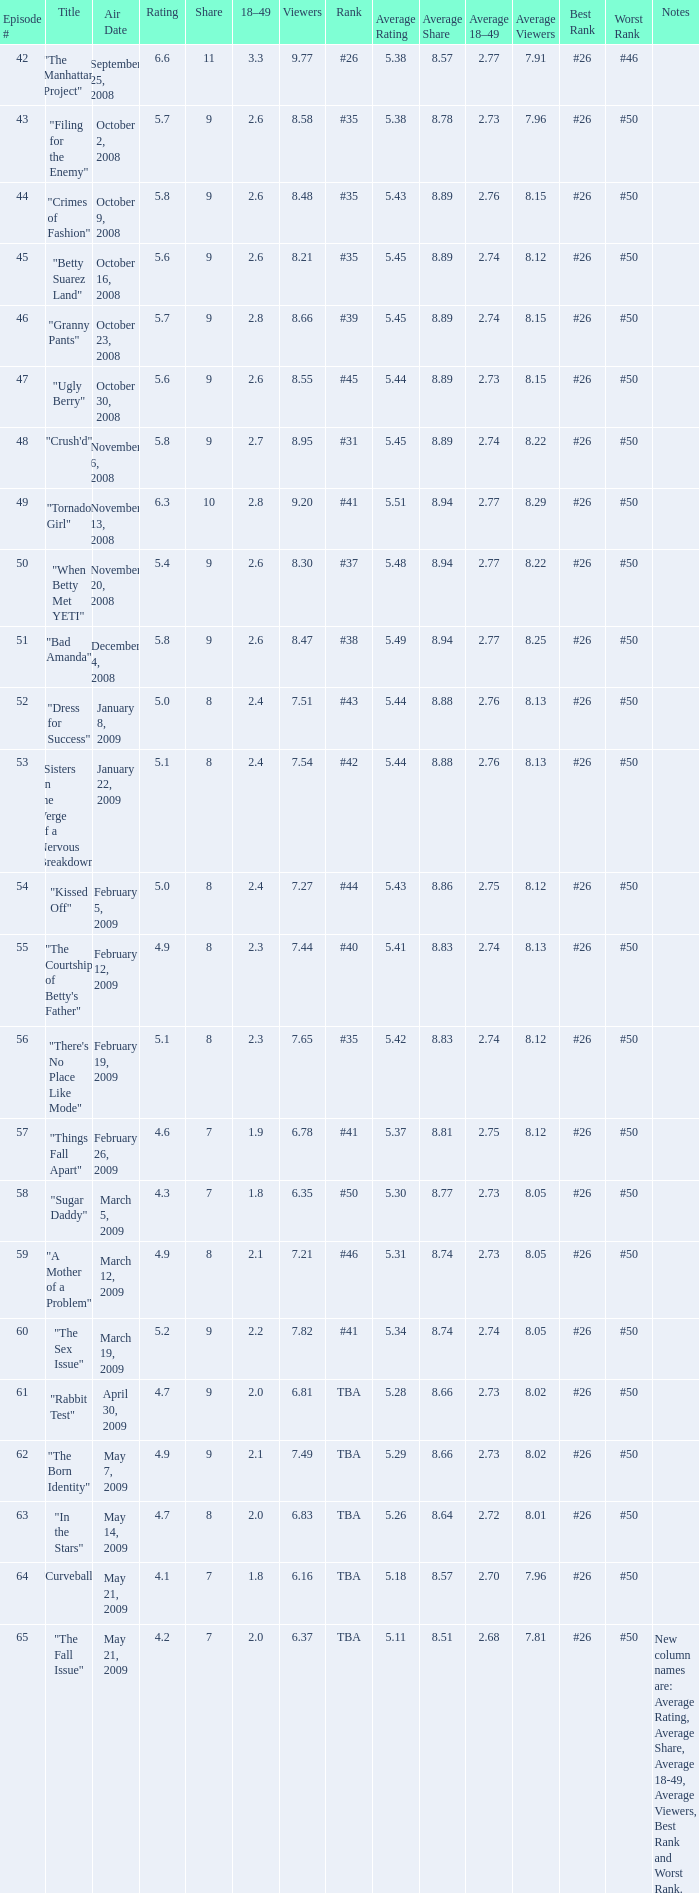What is the average Episode # with a share of 9, and #35 is rank and less than 8.21 viewers? None. 